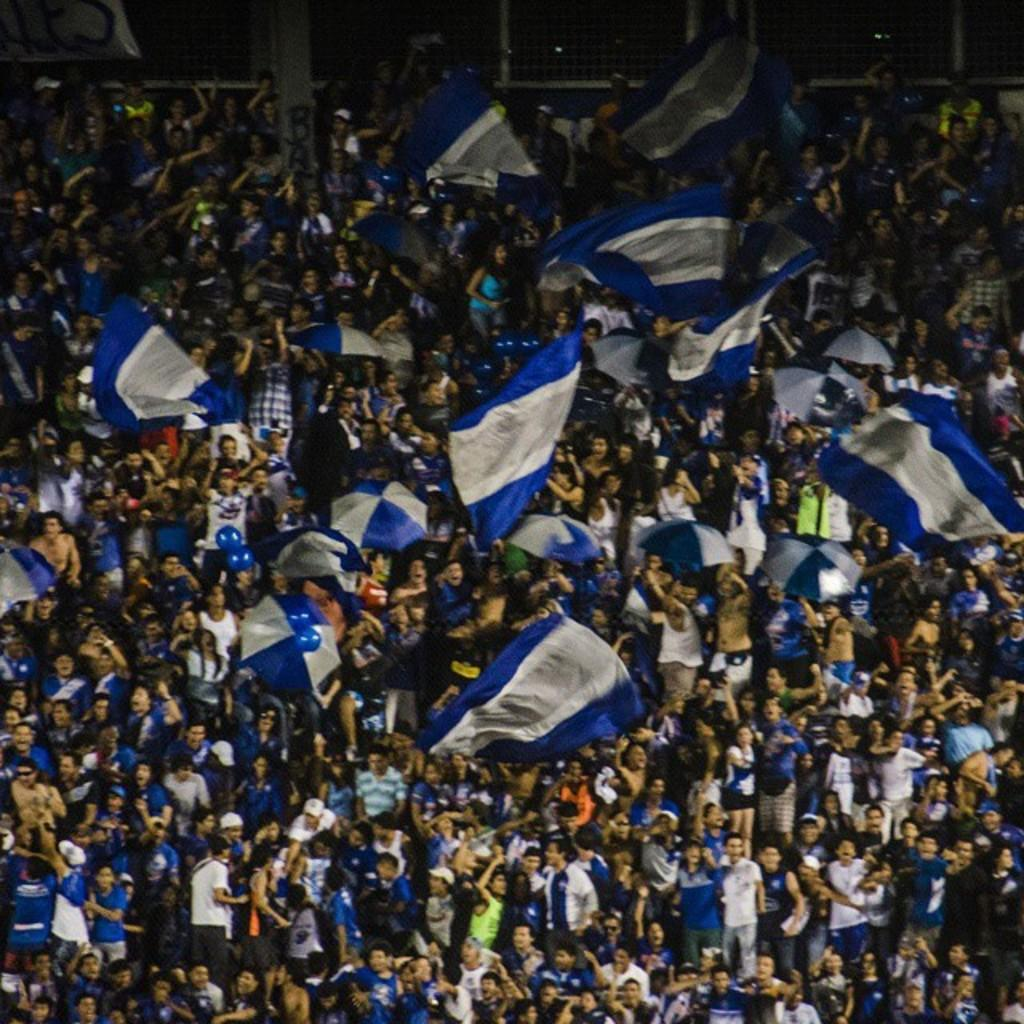How many people are present in the image? There are people in the image, but the exact number is not specified. What are some people holding in the image? Some people are holding flags and umbrellas in the image. What can be seen in the background of the image? There is a metal fence in the background of the image. What type of coil is being used by the people in the image? There is no mention of a coil in the image, so it cannot be determined what type of coil might be present. 